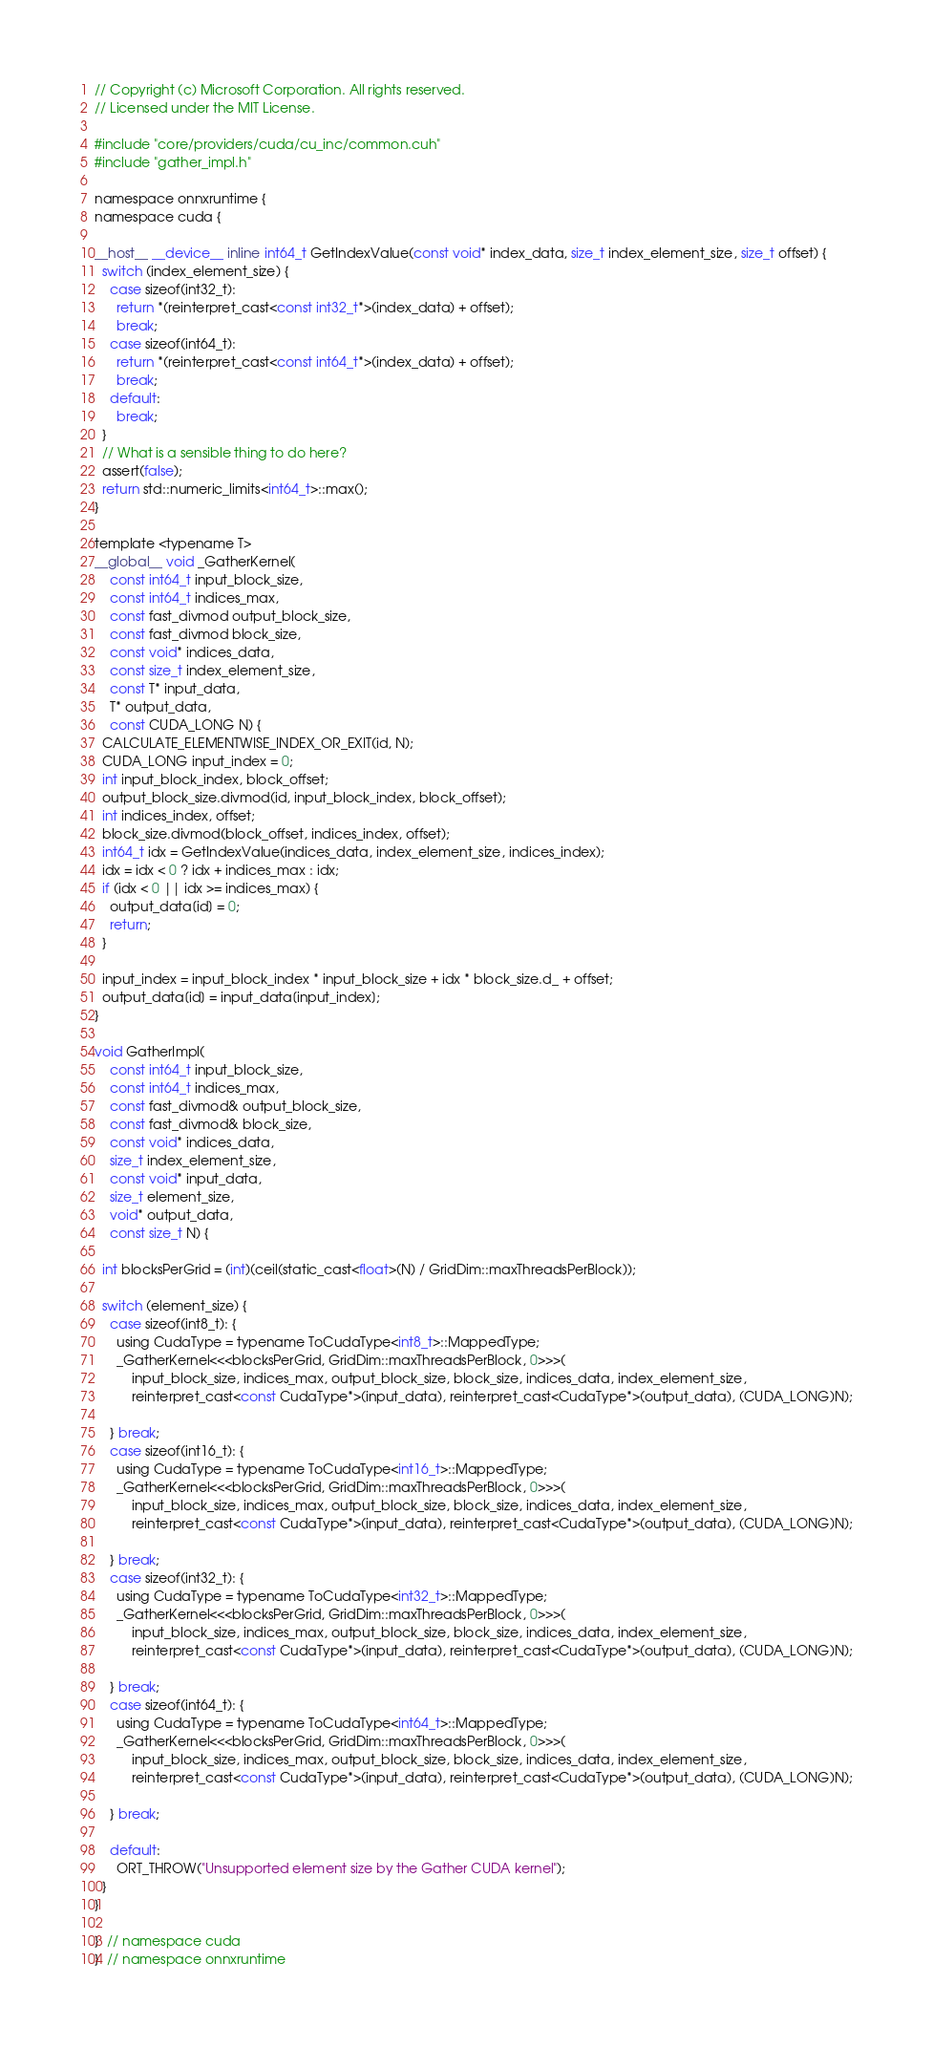<code> <loc_0><loc_0><loc_500><loc_500><_Cuda_>// Copyright (c) Microsoft Corporation. All rights reserved.
// Licensed under the MIT License.

#include "core/providers/cuda/cu_inc/common.cuh"
#include "gather_impl.h"

namespace onnxruntime {
namespace cuda {

__host__ __device__ inline int64_t GetIndexValue(const void* index_data, size_t index_element_size, size_t offset) {
  switch (index_element_size) {
    case sizeof(int32_t):
      return *(reinterpret_cast<const int32_t*>(index_data) + offset);
      break;
    case sizeof(int64_t):
      return *(reinterpret_cast<const int64_t*>(index_data) + offset);
      break;
    default:
      break;
  }
  // What is a sensible thing to do here?
  assert(false);
  return std::numeric_limits<int64_t>::max();
}

template <typename T>
__global__ void _GatherKernel(
    const int64_t input_block_size,
    const int64_t indices_max,
    const fast_divmod output_block_size,
    const fast_divmod block_size,
    const void* indices_data,
    const size_t index_element_size,
    const T* input_data,
    T* output_data,
    const CUDA_LONG N) {
  CALCULATE_ELEMENTWISE_INDEX_OR_EXIT(id, N);
  CUDA_LONG input_index = 0;
  int input_block_index, block_offset;
  output_block_size.divmod(id, input_block_index, block_offset);
  int indices_index, offset;
  block_size.divmod(block_offset, indices_index, offset);
  int64_t idx = GetIndexValue(indices_data, index_element_size, indices_index);
  idx = idx < 0 ? idx + indices_max : idx;
  if (idx < 0 || idx >= indices_max) {
    output_data[id] = 0;
    return;
  }

  input_index = input_block_index * input_block_size + idx * block_size.d_ + offset;
  output_data[id] = input_data[input_index];
}

void GatherImpl(
    const int64_t input_block_size,
    const int64_t indices_max,
    const fast_divmod& output_block_size,
    const fast_divmod& block_size,
    const void* indices_data,
    size_t index_element_size,
    const void* input_data,
    size_t element_size,
    void* output_data,
    const size_t N) {

  int blocksPerGrid = (int)(ceil(static_cast<float>(N) / GridDim::maxThreadsPerBlock));

  switch (element_size) {
    case sizeof(int8_t): {
      using CudaType = typename ToCudaType<int8_t>::MappedType;
      _GatherKernel<<<blocksPerGrid, GridDim::maxThreadsPerBlock, 0>>>(
          input_block_size, indices_max, output_block_size, block_size, indices_data, index_element_size,
          reinterpret_cast<const CudaType*>(input_data), reinterpret_cast<CudaType*>(output_data), (CUDA_LONG)N);

    } break;
    case sizeof(int16_t): {
      using CudaType = typename ToCudaType<int16_t>::MappedType;
      _GatherKernel<<<blocksPerGrid, GridDim::maxThreadsPerBlock, 0>>>(
          input_block_size, indices_max, output_block_size, block_size, indices_data, index_element_size,
          reinterpret_cast<const CudaType*>(input_data), reinterpret_cast<CudaType*>(output_data), (CUDA_LONG)N);

    } break;
    case sizeof(int32_t): {
      using CudaType = typename ToCudaType<int32_t>::MappedType;
      _GatherKernel<<<blocksPerGrid, GridDim::maxThreadsPerBlock, 0>>>(
          input_block_size, indices_max, output_block_size, block_size, indices_data, index_element_size,
          reinterpret_cast<const CudaType*>(input_data), reinterpret_cast<CudaType*>(output_data), (CUDA_LONG)N);

    } break;
    case sizeof(int64_t): {
      using CudaType = typename ToCudaType<int64_t>::MappedType;
      _GatherKernel<<<blocksPerGrid, GridDim::maxThreadsPerBlock, 0>>>(
          input_block_size, indices_max, output_block_size, block_size, indices_data, index_element_size,
          reinterpret_cast<const CudaType*>(input_data), reinterpret_cast<CudaType*>(output_data), (CUDA_LONG)N);

    } break;

    default:
      ORT_THROW("Unsupported element size by the Gather CUDA kernel");
  }
}

}  // namespace cuda
}  // namespace onnxruntime
</code> 